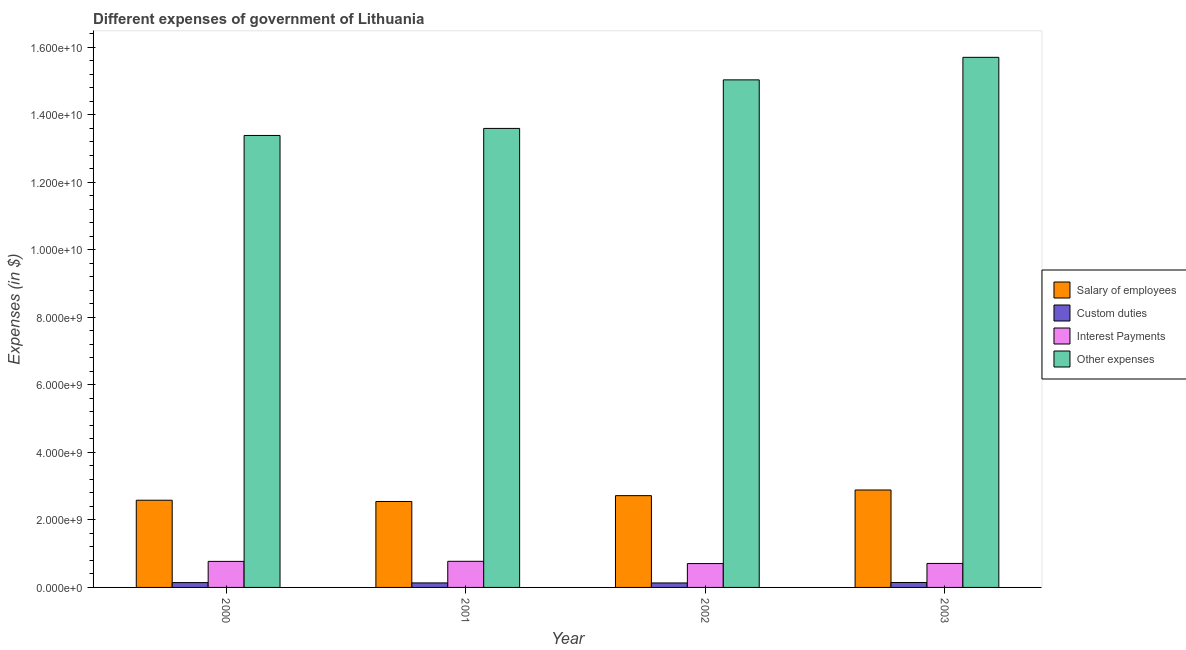How many different coloured bars are there?
Provide a short and direct response. 4. Are the number of bars per tick equal to the number of legend labels?
Ensure brevity in your answer.  Yes. How many bars are there on the 3rd tick from the right?
Make the answer very short. 4. What is the amount spent on salary of employees in 2000?
Keep it short and to the point. 2.58e+09. Across all years, what is the maximum amount spent on salary of employees?
Offer a terse response. 2.88e+09. Across all years, what is the minimum amount spent on interest payments?
Keep it short and to the point. 7.06e+08. In which year was the amount spent on interest payments maximum?
Offer a very short reply. 2001. In which year was the amount spent on other expenses minimum?
Provide a succinct answer. 2000. What is the total amount spent on custom duties in the graph?
Provide a short and direct response. 5.56e+08. What is the difference between the amount spent on interest payments in 2000 and that in 2001?
Provide a succinct answer. -2.30e+06. What is the difference between the amount spent on other expenses in 2001 and the amount spent on interest payments in 2002?
Keep it short and to the point. -1.44e+09. What is the average amount spent on salary of employees per year?
Provide a succinct answer. 2.68e+09. In how many years, is the amount spent on other expenses greater than 12000000000 $?
Provide a short and direct response. 4. What is the ratio of the amount spent on custom duties in 2001 to that in 2002?
Offer a terse response. 1.01. What is the difference between the highest and the second highest amount spent on interest payments?
Your response must be concise. 2.30e+06. What is the difference between the highest and the lowest amount spent on other expenses?
Ensure brevity in your answer.  2.31e+09. In how many years, is the amount spent on other expenses greater than the average amount spent on other expenses taken over all years?
Make the answer very short. 2. What does the 2nd bar from the left in 2003 represents?
Keep it short and to the point. Custom duties. What does the 1st bar from the right in 2001 represents?
Your answer should be compact. Other expenses. Is it the case that in every year, the sum of the amount spent on salary of employees and amount spent on custom duties is greater than the amount spent on interest payments?
Provide a short and direct response. Yes. How many bars are there?
Offer a terse response. 16. Are all the bars in the graph horizontal?
Your answer should be very brief. No. What is the difference between two consecutive major ticks on the Y-axis?
Your response must be concise. 2.00e+09. Where does the legend appear in the graph?
Make the answer very short. Center right. How many legend labels are there?
Provide a succinct answer. 4. How are the legend labels stacked?
Make the answer very short. Vertical. What is the title of the graph?
Offer a very short reply. Different expenses of government of Lithuania. What is the label or title of the X-axis?
Provide a short and direct response. Year. What is the label or title of the Y-axis?
Offer a terse response. Expenses (in $). What is the Expenses (in $) of Salary of employees in 2000?
Provide a succinct answer. 2.58e+09. What is the Expenses (in $) in Custom duties in 2000?
Provide a short and direct response. 1.43e+08. What is the Expenses (in $) of Interest Payments in 2000?
Provide a short and direct response. 7.71e+08. What is the Expenses (in $) in Other expenses in 2000?
Ensure brevity in your answer.  1.34e+1. What is the Expenses (in $) in Salary of employees in 2001?
Give a very brief answer. 2.55e+09. What is the Expenses (in $) in Custom duties in 2001?
Your answer should be compact. 1.34e+08. What is the Expenses (in $) in Interest Payments in 2001?
Offer a very short reply. 7.73e+08. What is the Expenses (in $) in Other expenses in 2001?
Keep it short and to the point. 1.36e+1. What is the Expenses (in $) in Salary of employees in 2002?
Keep it short and to the point. 2.72e+09. What is the Expenses (in $) of Custom duties in 2002?
Your answer should be compact. 1.32e+08. What is the Expenses (in $) in Interest Payments in 2002?
Your answer should be compact. 7.06e+08. What is the Expenses (in $) of Other expenses in 2002?
Ensure brevity in your answer.  1.50e+1. What is the Expenses (in $) of Salary of employees in 2003?
Your answer should be very brief. 2.88e+09. What is the Expenses (in $) of Custom duties in 2003?
Your answer should be compact. 1.46e+08. What is the Expenses (in $) in Interest Payments in 2003?
Give a very brief answer. 7.11e+08. What is the Expenses (in $) in Other expenses in 2003?
Offer a very short reply. 1.57e+1. Across all years, what is the maximum Expenses (in $) of Salary of employees?
Ensure brevity in your answer.  2.88e+09. Across all years, what is the maximum Expenses (in $) of Custom duties?
Offer a terse response. 1.46e+08. Across all years, what is the maximum Expenses (in $) in Interest Payments?
Make the answer very short. 7.73e+08. Across all years, what is the maximum Expenses (in $) in Other expenses?
Provide a succinct answer. 1.57e+1. Across all years, what is the minimum Expenses (in $) of Salary of employees?
Keep it short and to the point. 2.55e+09. Across all years, what is the minimum Expenses (in $) of Custom duties?
Your response must be concise. 1.32e+08. Across all years, what is the minimum Expenses (in $) of Interest Payments?
Give a very brief answer. 7.06e+08. Across all years, what is the minimum Expenses (in $) of Other expenses?
Your answer should be compact. 1.34e+1. What is the total Expenses (in $) of Salary of employees in the graph?
Your answer should be compact. 1.07e+1. What is the total Expenses (in $) of Custom duties in the graph?
Offer a terse response. 5.56e+08. What is the total Expenses (in $) of Interest Payments in the graph?
Keep it short and to the point. 2.96e+09. What is the total Expenses (in $) in Other expenses in the graph?
Your answer should be compact. 5.77e+1. What is the difference between the Expenses (in $) of Salary of employees in 2000 and that in 2001?
Your answer should be compact. 3.69e+07. What is the difference between the Expenses (in $) of Custom duties in 2000 and that in 2001?
Provide a succinct answer. 9.10e+06. What is the difference between the Expenses (in $) of Interest Payments in 2000 and that in 2001?
Offer a very short reply. -2.30e+06. What is the difference between the Expenses (in $) in Other expenses in 2000 and that in 2001?
Your answer should be compact. -2.09e+08. What is the difference between the Expenses (in $) in Salary of employees in 2000 and that in 2002?
Your answer should be compact. -1.36e+08. What is the difference between the Expenses (in $) of Custom duties in 2000 and that in 2002?
Ensure brevity in your answer.  1.04e+07. What is the difference between the Expenses (in $) of Interest Payments in 2000 and that in 2002?
Keep it short and to the point. 6.46e+07. What is the difference between the Expenses (in $) in Other expenses in 2000 and that in 2002?
Your answer should be very brief. -1.65e+09. What is the difference between the Expenses (in $) in Salary of employees in 2000 and that in 2003?
Your response must be concise. -3.03e+08. What is the difference between the Expenses (in $) of Custom duties in 2000 and that in 2003?
Give a very brief answer. -3.40e+06. What is the difference between the Expenses (in $) in Interest Payments in 2000 and that in 2003?
Offer a terse response. 6.04e+07. What is the difference between the Expenses (in $) of Other expenses in 2000 and that in 2003?
Make the answer very short. -2.31e+09. What is the difference between the Expenses (in $) of Salary of employees in 2001 and that in 2002?
Your answer should be very brief. -1.72e+08. What is the difference between the Expenses (in $) in Custom duties in 2001 and that in 2002?
Give a very brief answer. 1.30e+06. What is the difference between the Expenses (in $) in Interest Payments in 2001 and that in 2002?
Ensure brevity in your answer.  6.69e+07. What is the difference between the Expenses (in $) of Other expenses in 2001 and that in 2002?
Your answer should be compact. -1.44e+09. What is the difference between the Expenses (in $) in Salary of employees in 2001 and that in 2003?
Provide a succinct answer. -3.40e+08. What is the difference between the Expenses (in $) in Custom duties in 2001 and that in 2003?
Your response must be concise. -1.25e+07. What is the difference between the Expenses (in $) of Interest Payments in 2001 and that in 2003?
Your answer should be very brief. 6.27e+07. What is the difference between the Expenses (in $) of Other expenses in 2001 and that in 2003?
Provide a short and direct response. -2.10e+09. What is the difference between the Expenses (in $) in Salary of employees in 2002 and that in 2003?
Keep it short and to the point. -1.67e+08. What is the difference between the Expenses (in $) in Custom duties in 2002 and that in 2003?
Your answer should be very brief. -1.38e+07. What is the difference between the Expenses (in $) in Interest Payments in 2002 and that in 2003?
Your answer should be compact. -4.20e+06. What is the difference between the Expenses (in $) in Other expenses in 2002 and that in 2003?
Give a very brief answer. -6.67e+08. What is the difference between the Expenses (in $) in Salary of employees in 2000 and the Expenses (in $) in Custom duties in 2001?
Provide a short and direct response. 2.45e+09. What is the difference between the Expenses (in $) of Salary of employees in 2000 and the Expenses (in $) of Interest Payments in 2001?
Offer a terse response. 1.81e+09. What is the difference between the Expenses (in $) in Salary of employees in 2000 and the Expenses (in $) in Other expenses in 2001?
Your response must be concise. -1.10e+1. What is the difference between the Expenses (in $) in Custom duties in 2000 and the Expenses (in $) in Interest Payments in 2001?
Offer a very short reply. -6.30e+08. What is the difference between the Expenses (in $) of Custom duties in 2000 and the Expenses (in $) of Other expenses in 2001?
Keep it short and to the point. -1.34e+1. What is the difference between the Expenses (in $) of Interest Payments in 2000 and the Expenses (in $) of Other expenses in 2001?
Give a very brief answer. -1.28e+1. What is the difference between the Expenses (in $) in Salary of employees in 2000 and the Expenses (in $) in Custom duties in 2002?
Ensure brevity in your answer.  2.45e+09. What is the difference between the Expenses (in $) of Salary of employees in 2000 and the Expenses (in $) of Interest Payments in 2002?
Keep it short and to the point. 1.88e+09. What is the difference between the Expenses (in $) of Salary of employees in 2000 and the Expenses (in $) of Other expenses in 2002?
Offer a very short reply. -1.24e+1. What is the difference between the Expenses (in $) of Custom duties in 2000 and the Expenses (in $) of Interest Payments in 2002?
Make the answer very short. -5.64e+08. What is the difference between the Expenses (in $) in Custom duties in 2000 and the Expenses (in $) in Other expenses in 2002?
Keep it short and to the point. -1.49e+1. What is the difference between the Expenses (in $) in Interest Payments in 2000 and the Expenses (in $) in Other expenses in 2002?
Provide a short and direct response. -1.43e+1. What is the difference between the Expenses (in $) of Salary of employees in 2000 and the Expenses (in $) of Custom duties in 2003?
Keep it short and to the point. 2.44e+09. What is the difference between the Expenses (in $) of Salary of employees in 2000 and the Expenses (in $) of Interest Payments in 2003?
Give a very brief answer. 1.87e+09. What is the difference between the Expenses (in $) of Salary of employees in 2000 and the Expenses (in $) of Other expenses in 2003?
Your answer should be compact. -1.31e+1. What is the difference between the Expenses (in $) of Custom duties in 2000 and the Expenses (in $) of Interest Payments in 2003?
Offer a terse response. -5.68e+08. What is the difference between the Expenses (in $) of Custom duties in 2000 and the Expenses (in $) of Other expenses in 2003?
Ensure brevity in your answer.  -1.56e+1. What is the difference between the Expenses (in $) in Interest Payments in 2000 and the Expenses (in $) in Other expenses in 2003?
Your answer should be compact. -1.49e+1. What is the difference between the Expenses (in $) of Salary of employees in 2001 and the Expenses (in $) of Custom duties in 2002?
Give a very brief answer. 2.41e+09. What is the difference between the Expenses (in $) of Salary of employees in 2001 and the Expenses (in $) of Interest Payments in 2002?
Make the answer very short. 1.84e+09. What is the difference between the Expenses (in $) in Salary of employees in 2001 and the Expenses (in $) in Other expenses in 2002?
Keep it short and to the point. -1.25e+1. What is the difference between the Expenses (in $) in Custom duties in 2001 and the Expenses (in $) in Interest Payments in 2002?
Your response must be concise. -5.73e+08. What is the difference between the Expenses (in $) in Custom duties in 2001 and the Expenses (in $) in Other expenses in 2002?
Offer a terse response. -1.49e+1. What is the difference between the Expenses (in $) in Interest Payments in 2001 and the Expenses (in $) in Other expenses in 2002?
Give a very brief answer. -1.43e+1. What is the difference between the Expenses (in $) of Salary of employees in 2001 and the Expenses (in $) of Custom duties in 2003?
Your answer should be compact. 2.40e+09. What is the difference between the Expenses (in $) in Salary of employees in 2001 and the Expenses (in $) in Interest Payments in 2003?
Offer a very short reply. 1.83e+09. What is the difference between the Expenses (in $) in Salary of employees in 2001 and the Expenses (in $) in Other expenses in 2003?
Make the answer very short. -1.32e+1. What is the difference between the Expenses (in $) of Custom duties in 2001 and the Expenses (in $) of Interest Payments in 2003?
Give a very brief answer. -5.77e+08. What is the difference between the Expenses (in $) in Custom duties in 2001 and the Expenses (in $) in Other expenses in 2003?
Your answer should be very brief. -1.56e+1. What is the difference between the Expenses (in $) in Interest Payments in 2001 and the Expenses (in $) in Other expenses in 2003?
Provide a succinct answer. -1.49e+1. What is the difference between the Expenses (in $) of Salary of employees in 2002 and the Expenses (in $) of Custom duties in 2003?
Ensure brevity in your answer.  2.57e+09. What is the difference between the Expenses (in $) of Salary of employees in 2002 and the Expenses (in $) of Interest Payments in 2003?
Provide a short and direct response. 2.01e+09. What is the difference between the Expenses (in $) of Salary of employees in 2002 and the Expenses (in $) of Other expenses in 2003?
Keep it short and to the point. -1.30e+1. What is the difference between the Expenses (in $) in Custom duties in 2002 and the Expenses (in $) in Interest Payments in 2003?
Your answer should be very brief. -5.78e+08. What is the difference between the Expenses (in $) of Custom duties in 2002 and the Expenses (in $) of Other expenses in 2003?
Make the answer very short. -1.56e+1. What is the difference between the Expenses (in $) in Interest Payments in 2002 and the Expenses (in $) in Other expenses in 2003?
Your response must be concise. -1.50e+1. What is the average Expenses (in $) in Salary of employees per year?
Your answer should be compact. 2.68e+09. What is the average Expenses (in $) in Custom duties per year?
Ensure brevity in your answer.  1.39e+08. What is the average Expenses (in $) in Interest Payments per year?
Your answer should be compact. 7.40e+08. What is the average Expenses (in $) of Other expenses per year?
Make the answer very short. 1.44e+1. In the year 2000, what is the difference between the Expenses (in $) in Salary of employees and Expenses (in $) in Custom duties?
Make the answer very short. 2.44e+09. In the year 2000, what is the difference between the Expenses (in $) in Salary of employees and Expenses (in $) in Interest Payments?
Make the answer very short. 1.81e+09. In the year 2000, what is the difference between the Expenses (in $) in Salary of employees and Expenses (in $) in Other expenses?
Your answer should be very brief. -1.08e+1. In the year 2000, what is the difference between the Expenses (in $) in Custom duties and Expenses (in $) in Interest Payments?
Make the answer very short. -6.28e+08. In the year 2000, what is the difference between the Expenses (in $) in Custom duties and Expenses (in $) in Other expenses?
Your answer should be compact. -1.32e+1. In the year 2000, what is the difference between the Expenses (in $) of Interest Payments and Expenses (in $) of Other expenses?
Offer a very short reply. -1.26e+1. In the year 2001, what is the difference between the Expenses (in $) in Salary of employees and Expenses (in $) in Custom duties?
Keep it short and to the point. 2.41e+09. In the year 2001, what is the difference between the Expenses (in $) of Salary of employees and Expenses (in $) of Interest Payments?
Your answer should be very brief. 1.77e+09. In the year 2001, what is the difference between the Expenses (in $) in Salary of employees and Expenses (in $) in Other expenses?
Your response must be concise. -1.10e+1. In the year 2001, what is the difference between the Expenses (in $) in Custom duties and Expenses (in $) in Interest Payments?
Offer a terse response. -6.40e+08. In the year 2001, what is the difference between the Expenses (in $) in Custom duties and Expenses (in $) in Other expenses?
Provide a succinct answer. -1.35e+1. In the year 2001, what is the difference between the Expenses (in $) of Interest Payments and Expenses (in $) of Other expenses?
Ensure brevity in your answer.  -1.28e+1. In the year 2002, what is the difference between the Expenses (in $) of Salary of employees and Expenses (in $) of Custom duties?
Your response must be concise. 2.59e+09. In the year 2002, what is the difference between the Expenses (in $) in Salary of employees and Expenses (in $) in Interest Payments?
Your answer should be compact. 2.01e+09. In the year 2002, what is the difference between the Expenses (in $) of Salary of employees and Expenses (in $) of Other expenses?
Give a very brief answer. -1.23e+1. In the year 2002, what is the difference between the Expenses (in $) in Custom duties and Expenses (in $) in Interest Payments?
Keep it short and to the point. -5.74e+08. In the year 2002, what is the difference between the Expenses (in $) of Custom duties and Expenses (in $) of Other expenses?
Give a very brief answer. -1.49e+1. In the year 2002, what is the difference between the Expenses (in $) in Interest Payments and Expenses (in $) in Other expenses?
Your answer should be compact. -1.43e+1. In the year 2003, what is the difference between the Expenses (in $) of Salary of employees and Expenses (in $) of Custom duties?
Provide a succinct answer. 2.74e+09. In the year 2003, what is the difference between the Expenses (in $) of Salary of employees and Expenses (in $) of Interest Payments?
Your answer should be very brief. 2.17e+09. In the year 2003, what is the difference between the Expenses (in $) of Salary of employees and Expenses (in $) of Other expenses?
Your response must be concise. -1.28e+1. In the year 2003, what is the difference between the Expenses (in $) in Custom duties and Expenses (in $) in Interest Payments?
Your answer should be very brief. -5.64e+08. In the year 2003, what is the difference between the Expenses (in $) of Custom duties and Expenses (in $) of Other expenses?
Make the answer very short. -1.56e+1. In the year 2003, what is the difference between the Expenses (in $) in Interest Payments and Expenses (in $) in Other expenses?
Ensure brevity in your answer.  -1.50e+1. What is the ratio of the Expenses (in $) in Salary of employees in 2000 to that in 2001?
Your answer should be compact. 1.01. What is the ratio of the Expenses (in $) in Custom duties in 2000 to that in 2001?
Offer a very short reply. 1.07. What is the ratio of the Expenses (in $) in Other expenses in 2000 to that in 2001?
Keep it short and to the point. 0.98. What is the ratio of the Expenses (in $) in Salary of employees in 2000 to that in 2002?
Give a very brief answer. 0.95. What is the ratio of the Expenses (in $) in Custom duties in 2000 to that in 2002?
Your answer should be compact. 1.08. What is the ratio of the Expenses (in $) in Interest Payments in 2000 to that in 2002?
Offer a very short reply. 1.09. What is the ratio of the Expenses (in $) of Other expenses in 2000 to that in 2002?
Offer a very short reply. 0.89. What is the ratio of the Expenses (in $) of Salary of employees in 2000 to that in 2003?
Your response must be concise. 0.9. What is the ratio of the Expenses (in $) in Custom duties in 2000 to that in 2003?
Provide a succinct answer. 0.98. What is the ratio of the Expenses (in $) of Interest Payments in 2000 to that in 2003?
Your response must be concise. 1.08. What is the ratio of the Expenses (in $) in Other expenses in 2000 to that in 2003?
Provide a short and direct response. 0.85. What is the ratio of the Expenses (in $) of Salary of employees in 2001 to that in 2002?
Your answer should be very brief. 0.94. What is the ratio of the Expenses (in $) of Custom duties in 2001 to that in 2002?
Offer a very short reply. 1.01. What is the ratio of the Expenses (in $) of Interest Payments in 2001 to that in 2002?
Offer a very short reply. 1.09. What is the ratio of the Expenses (in $) of Other expenses in 2001 to that in 2002?
Provide a succinct answer. 0.9. What is the ratio of the Expenses (in $) of Salary of employees in 2001 to that in 2003?
Keep it short and to the point. 0.88. What is the ratio of the Expenses (in $) in Custom duties in 2001 to that in 2003?
Keep it short and to the point. 0.91. What is the ratio of the Expenses (in $) in Interest Payments in 2001 to that in 2003?
Offer a very short reply. 1.09. What is the ratio of the Expenses (in $) in Other expenses in 2001 to that in 2003?
Make the answer very short. 0.87. What is the ratio of the Expenses (in $) of Salary of employees in 2002 to that in 2003?
Provide a short and direct response. 0.94. What is the ratio of the Expenses (in $) of Custom duties in 2002 to that in 2003?
Give a very brief answer. 0.91. What is the ratio of the Expenses (in $) of Interest Payments in 2002 to that in 2003?
Provide a short and direct response. 0.99. What is the ratio of the Expenses (in $) of Other expenses in 2002 to that in 2003?
Provide a succinct answer. 0.96. What is the difference between the highest and the second highest Expenses (in $) of Salary of employees?
Offer a terse response. 1.67e+08. What is the difference between the highest and the second highest Expenses (in $) of Custom duties?
Your answer should be compact. 3.40e+06. What is the difference between the highest and the second highest Expenses (in $) in Interest Payments?
Your answer should be compact. 2.30e+06. What is the difference between the highest and the second highest Expenses (in $) of Other expenses?
Ensure brevity in your answer.  6.67e+08. What is the difference between the highest and the lowest Expenses (in $) in Salary of employees?
Your answer should be very brief. 3.40e+08. What is the difference between the highest and the lowest Expenses (in $) of Custom duties?
Provide a short and direct response. 1.38e+07. What is the difference between the highest and the lowest Expenses (in $) of Interest Payments?
Make the answer very short. 6.69e+07. What is the difference between the highest and the lowest Expenses (in $) in Other expenses?
Give a very brief answer. 2.31e+09. 